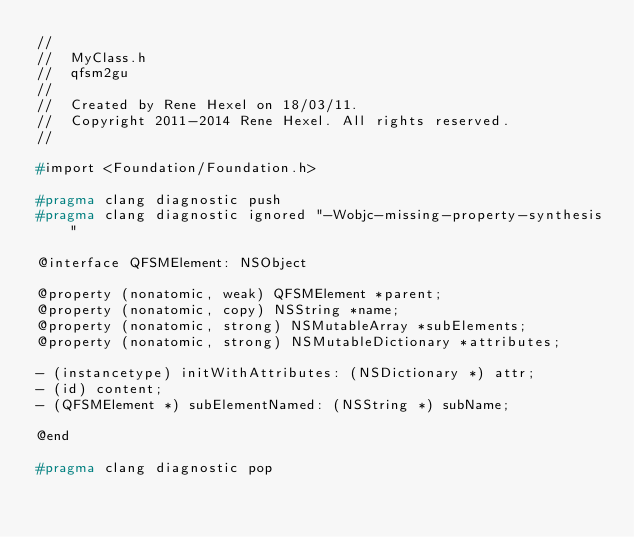Convert code to text. <code><loc_0><loc_0><loc_500><loc_500><_C_>//
//  MyClass.h
//  qfsm2gu
//
//  Created by Rene Hexel on 18/03/11.
//  Copyright 2011-2014 Rene Hexel. All rights reserved.
//

#import <Foundation/Foundation.h>

#pragma clang diagnostic push
#pragma clang diagnostic ignored "-Wobjc-missing-property-synthesis"

@interface QFSMElement: NSObject

@property (nonatomic, weak) QFSMElement *parent;
@property (nonatomic, copy) NSString *name;
@property (nonatomic, strong) NSMutableArray *subElements;
@property (nonatomic, strong) NSMutableDictionary *attributes;

- (instancetype) initWithAttributes: (NSDictionary *) attr;
- (id) content;
- (QFSMElement *) subElementNamed: (NSString *) subName;

@end

#pragma clang diagnostic pop
</code> 